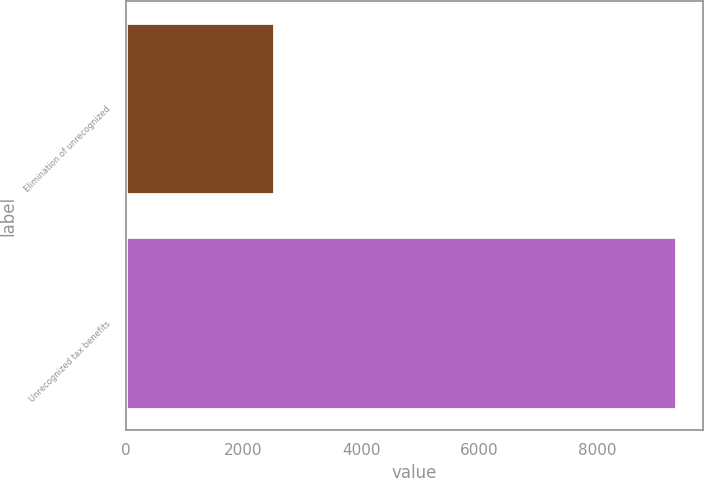Convert chart. <chart><loc_0><loc_0><loc_500><loc_500><bar_chart><fcel>Elimination of unrecognized<fcel>Unrecognized tax benefits<nl><fcel>2519<fcel>9334<nl></chart> 